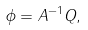Convert formula to latex. <formula><loc_0><loc_0><loc_500><loc_500>\phi = A ^ { - 1 } Q ,</formula> 